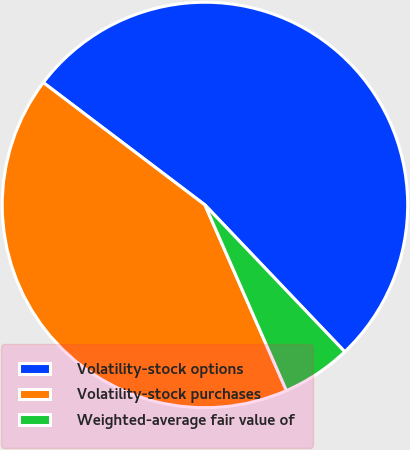Convert chart. <chart><loc_0><loc_0><loc_500><loc_500><pie_chart><fcel>Volatility-stock options<fcel>Volatility-stock purchases<fcel>Weighted-average fair value of<nl><fcel>52.58%<fcel>41.9%<fcel>5.53%<nl></chart> 